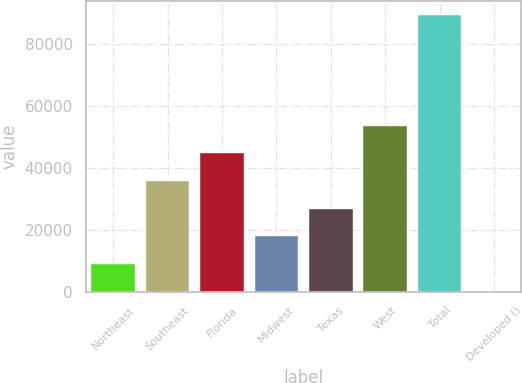Convert chart. <chart><loc_0><loc_0><loc_500><loc_500><bar_chart><fcel>Northeast<fcel>Southeast<fcel>Florida<fcel>Midwest<fcel>Texas<fcel>West<fcel>Total<fcel>Developed ()<nl><fcel>8988.1<fcel>35835.4<fcel>44784.5<fcel>17937.2<fcel>26886.3<fcel>53733.6<fcel>89530<fcel>39<nl></chart> 